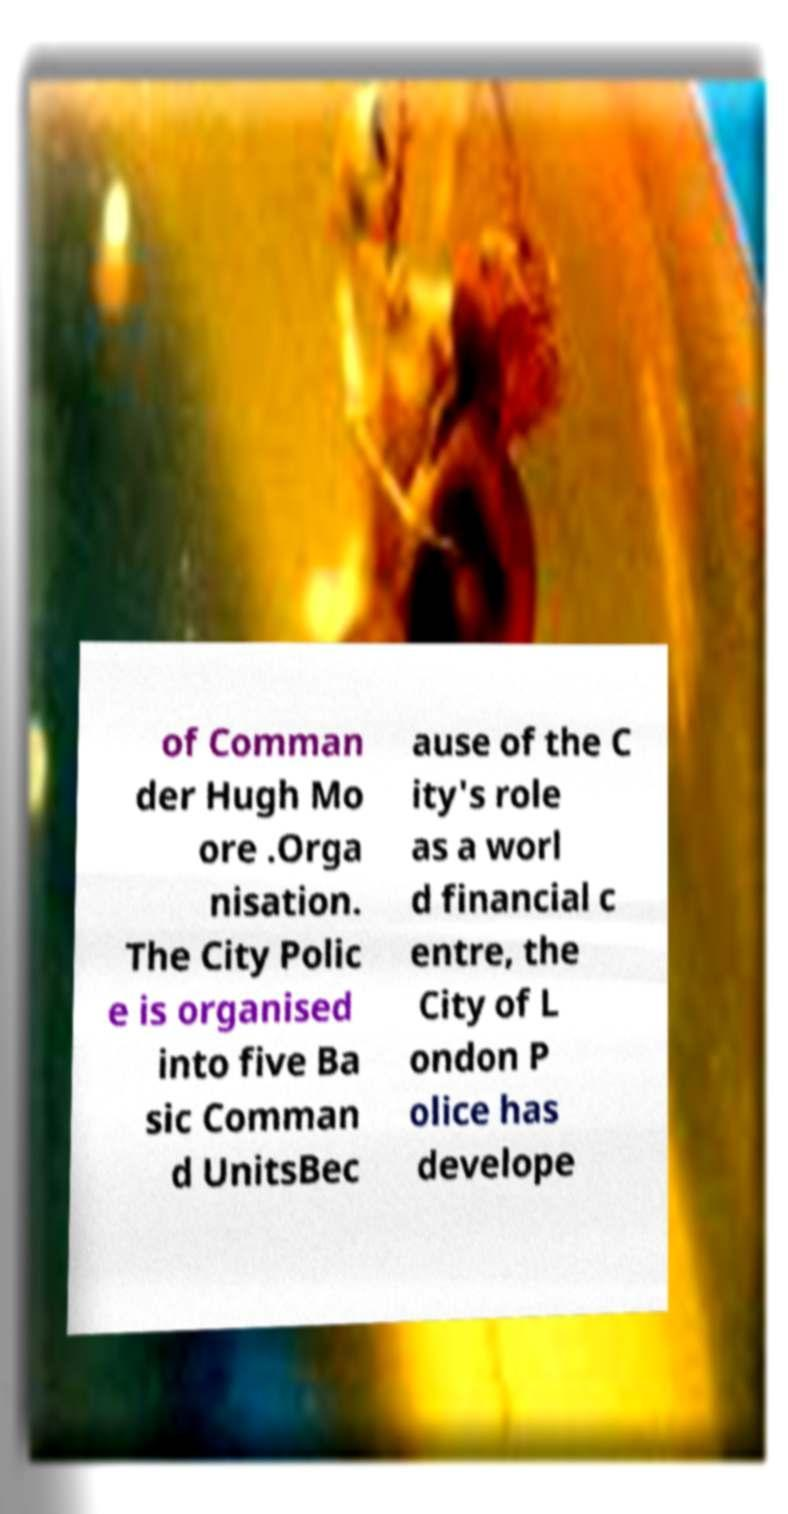I need the written content from this picture converted into text. Can you do that? of Comman der Hugh Mo ore .Orga nisation. The City Polic e is organised into five Ba sic Comman d UnitsBec ause of the C ity's role as a worl d financial c entre, the City of L ondon P olice has develope 